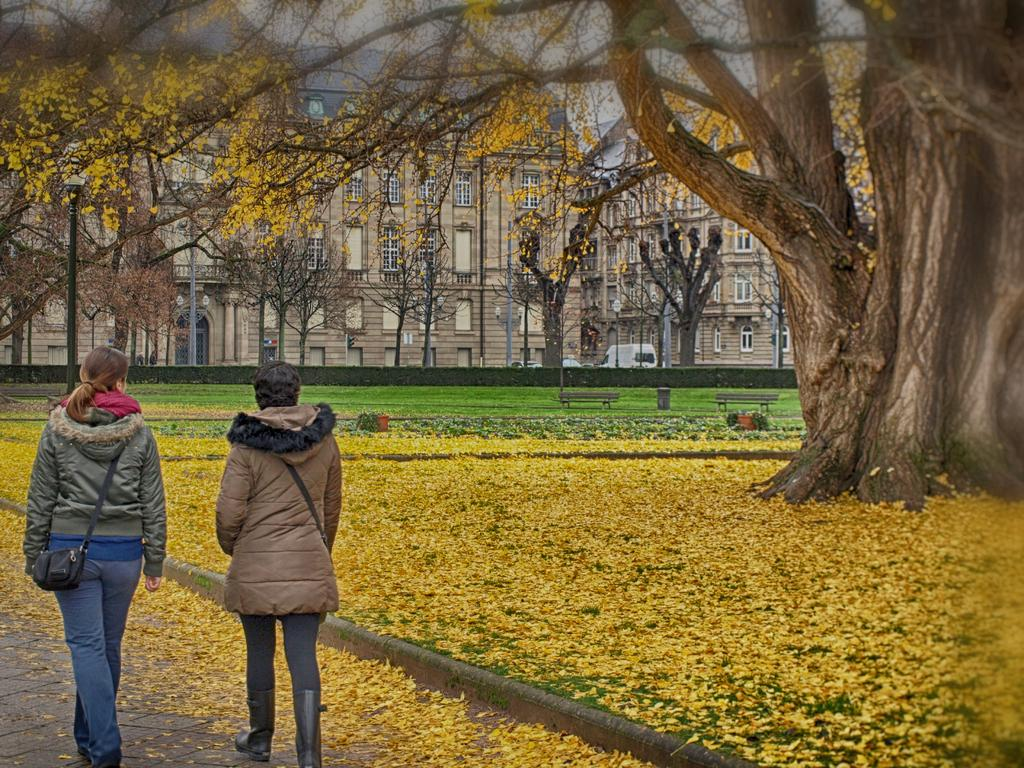How many people are in the image? There are two women in the image. Where are the women located in the image? The women are on the left side of the image. What can be seen in the background of the image? There is a big tree in the image. What type of cup is being used to water the cloth on the trail in the image? There is no cup, cloth, or trail present in the image. 